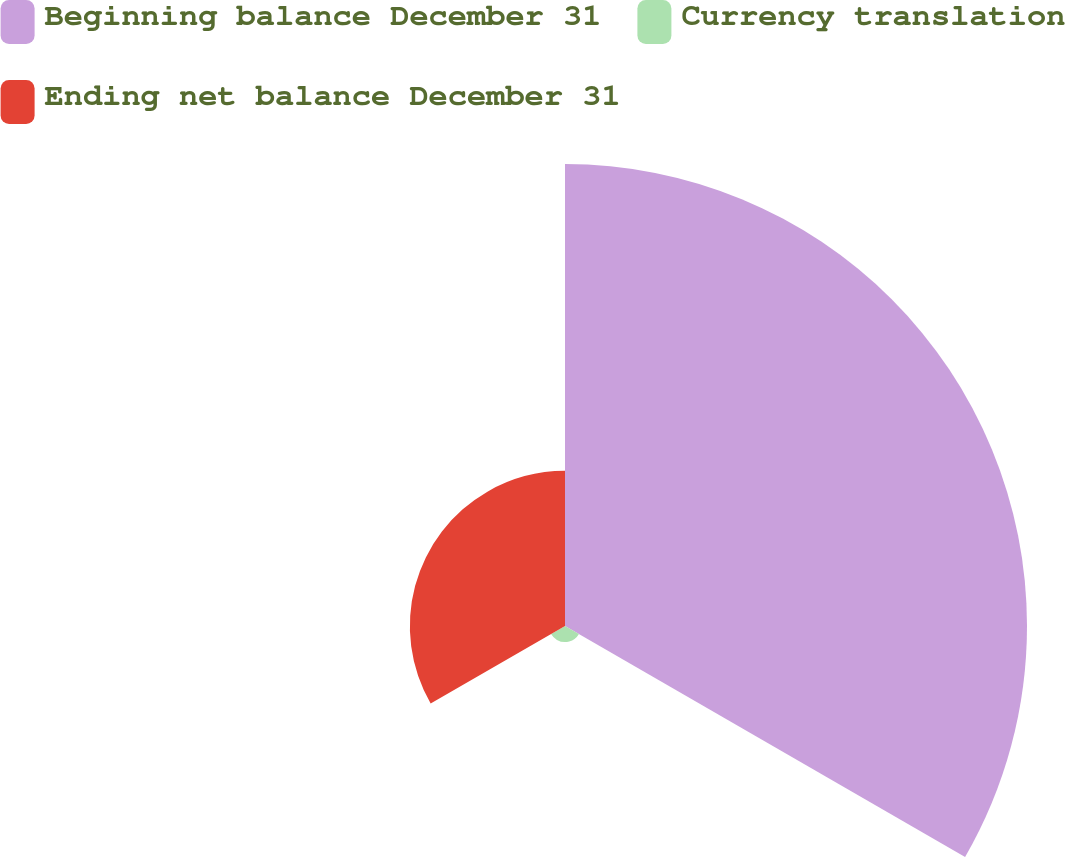Convert chart to OTSL. <chart><loc_0><loc_0><loc_500><loc_500><pie_chart><fcel>Beginning balance December 31<fcel>Currency translation<fcel>Ending net balance December 31<nl><fcel>72.96%<fcel>2.54%<fcel>24.5%<nl></chart> 